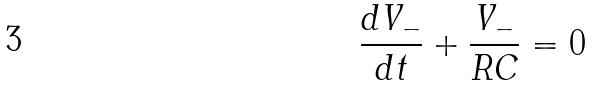Convert formula to latex. <formula><loc_0><loc_0><loc_500><loc_500>\frac { d V _ { - } } { d t } + \frac { V _ { - } } { R C } = 0</formula> 